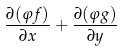Convert formula to latex. <formula><loc_0><loc_0><loc_500><loc_500>\frac { \partial ( \varphi f ) } { \partial x } + \frac { \partial ( \varphi g ) } { \partial y }</formula> 